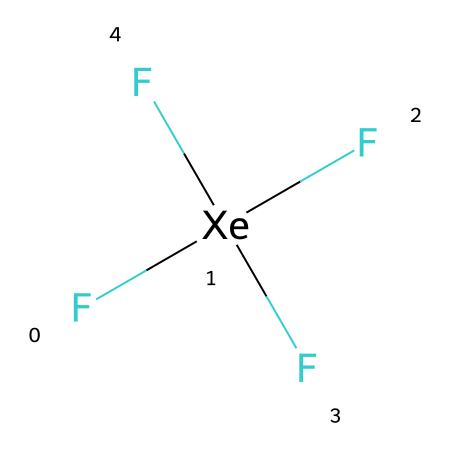What is the central atom in xenon tetrafluoride? The structure indicates that xenon (Xe) is the atom bonded to four fluorine (F) atoms, making it the central atom.
Answer: xenon How many fluorine atoms are attached to the xenon atom? By examining the SMILES representation, there are four fluorine atoms (F) directly connected to the xenon (Xe) atom.
Answer: four What type of hybridization is present in xenon tetrafluoride? The arrangement of four bonding pairs around the xenon atom suggests sp³d hybridization, which accommodates the hypervalent nature of xenon.
Answer: sp³d What is the molecular shape of xenon tetrafluoride? Given the presence of four bonded fluorine atoms and no lone pairs on the xenon, the molecular shape is determined to be square planar.
Answer: square planar How does the presence of hypervalence affect xenon tetrafluoride? The hypervalent nature allows xenon to expand its valence shell beyond eight electrons, enabling it to bond with four fluorine atoms simultaneously.
Answer: hypervalent What is the bond angle between the fluorine atoms in xenon tetrafluoride? In a square planar arrangement, the bond angle between adjacent fluorine atoms is 90 degrees.
Answer: 90 degrees 